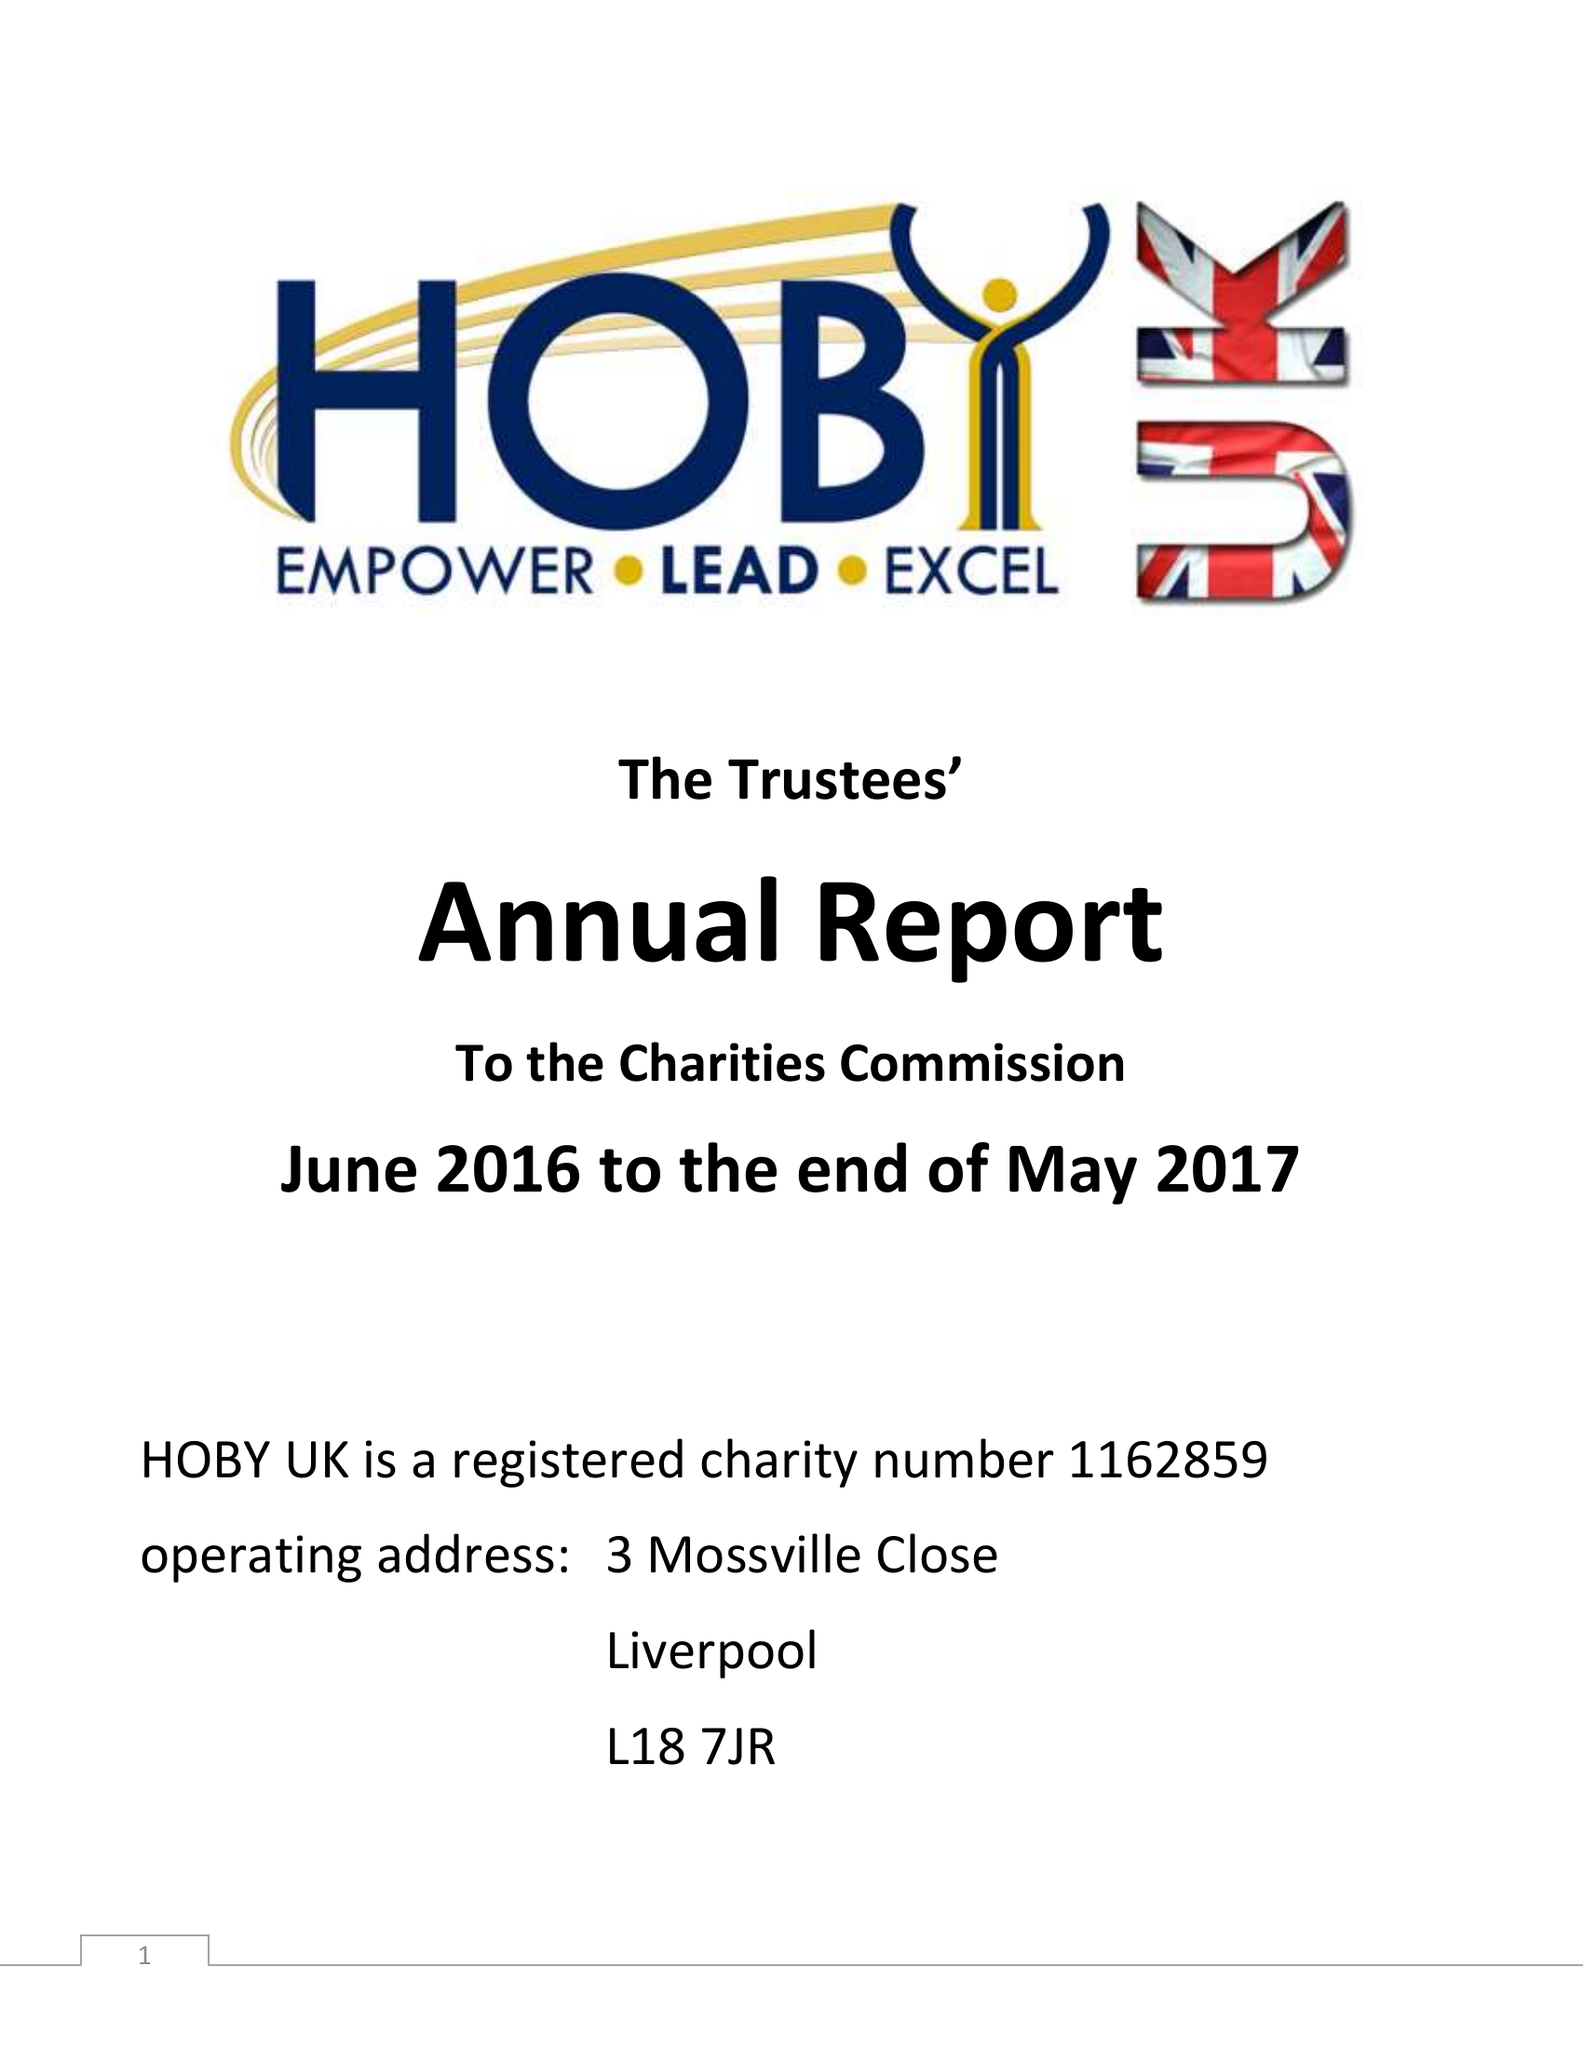What is the value for the charity_name?
Answer the question using a single word or phrase. Hoby Uk 